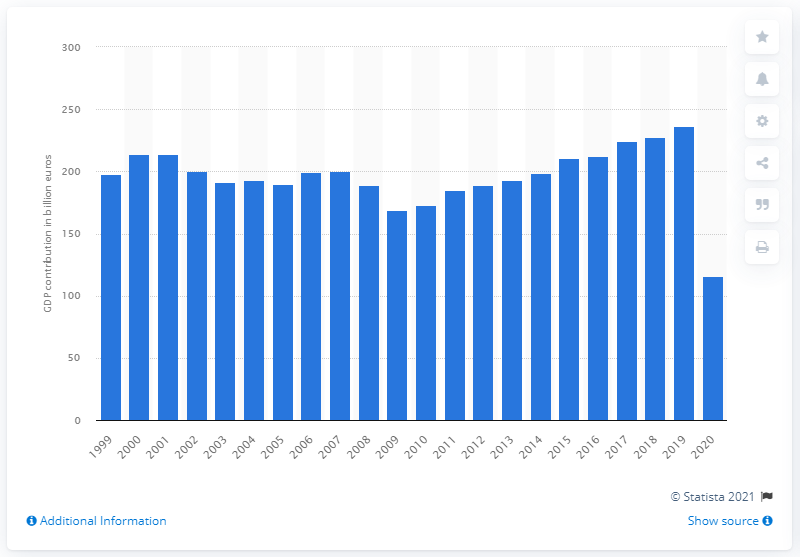Indicate a few pertinent items in this graphic. In 2020, the travel and tourism industry contributed significantly to the Gross Domestic Product (GDP) of Italy, with a total contribution of 115.8%. In 2020, travel and tourism accounted for 115.8% of Italy's Gross Domestic Product (GDP). 